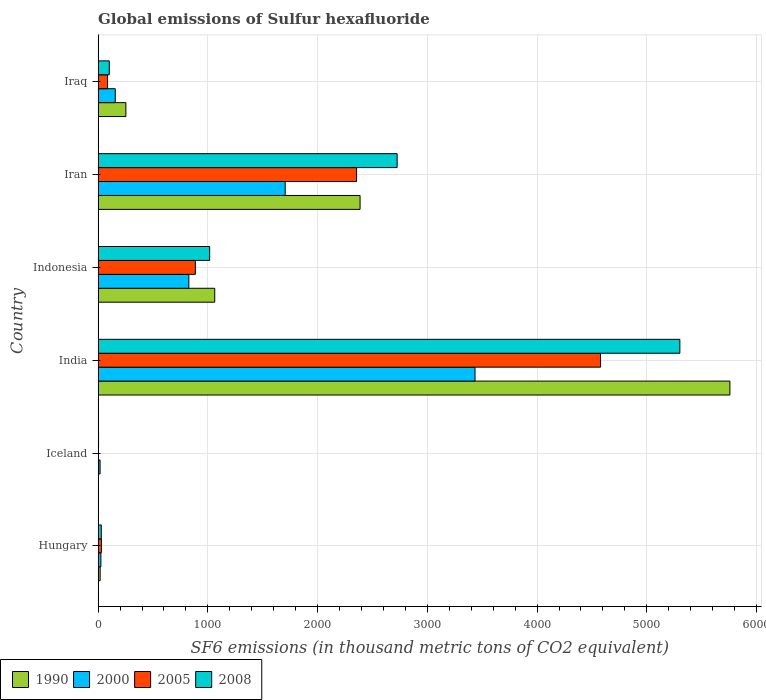How many different coloured bars are there?
Keep it short and to the point. 4. How many groups of bars are there?
Give a very brief answer. 6. Are the number of bars per tick equal to the number of legend labels?
Your answer should be very brief. Yes. Are the number of bars on each tick of the Y-axis equal?
Offer a terse response. Yes. How many bars are there on the 1st tick from the top?
Give a very brief answer. 4. What is the global emissions of Sulfur hexafluoride in 2000 in Iran?
Provide a short and direct response. 1704.9. Across all countries, what is the maximum global emissions of Sulfur hexafluoride in 2008?
Ensure brevity in your answer.  5301.4. Across all countries, what is the minimum global emissions of Sulfur hexafluoride in 2008?
Keep it short and to the point. 4. In which country was the global emissions of Sulfur hexafluoride in 2008 maximum?
Your response must be concise. India. In which country was the global emissions of Sulfur hexafluoride in 2000 minimum?
Provide a short and direct response. Iceland. What is the total global emissions of Sulfur hexafluoride in 1990 in the graph?
Your answer should be very brief. 9482.6. What is the difference between the global emissions of Sulfur hexafluoride in 1990 in India and that in Indonesia?
Provide a short and direct response. 4694.7. What is the difference between the global emissions of Sulfur hexafluoride in 2005 in Iran and the global emissions of Sulfur hexafluoride in 1990 in Indonesia?
Make the answer very short. 1292.7. What is the average global emissions of Sulfur hexafluoride in 2000 per country?
Make the answer very short. 1027.6. What is the difference between the global emissions of Sulfur hexafluoride in 2005 and global emissions of Sulfur hexafluoride in 2008 in Hungary?
Give a very brief answer. 1.1. In how many countries, is the global emissions of Sulfur hexafluoride in 2008 greater than 3200 thousand metric tons?
Make the answer very short. 1. What is the ratio of the global emissions of Sulfur hexafluoride in 1990 in Iceland to that in Iraq?
Ensure brevity in your answer.  0.01. Is the difference between the global emissions of Sulfur hexafluoride in 2005 in Indonesia and Iran greater than the difference between the global emissions of Sulfur hexafluoride in 2008 in Indonesia and Iran?
Keep it short and to the point. Yes. What is the difference between the highest and the second highest global emissions of Sulfur hexafluoride in 2008?
Ensure brevity in your answer.  2576.5. What is the difference between the highest and the lowest global emissions of Sulfur hexafluoride in 2000?
Keep it short and to the point. 3416.8. In how many countries, is the global emissions of Sulfur hexafluoride in 2005 greater than the average global emissions of Sulfur hexafluoride in 2005 taken over all countries?
Your answer should be very brief. 2. Is the sum of the global emissions of Sulfur hexafluoride in 2000 in Iceland and India greater than the maximum global emissions of Sulfur hexafluoride in 2008 across all countries?
Your answer should be very brief. No. What does the 1st bar from the top in Iceland represents?
Your answer should be compact. 2008. Are all the bars in the graph horizontal?
Give a very brief answer. Yes. Where does the legend appear in the graph?
Provide a succinct answer. Bottom left. How are the legend labels stacked?
Offer a very short reply. Horizontal. What is the title of the graph?
Offer a very short reply. Global emissions of Sulfur hexafluoride. What is the label or title of the X-axis?
Ensure brevity in your answer.  SF6 emissions (in thousand metric tons of CO2 equivalent). What is the label or title of the Y-axis?
Your answer should be compact. Country. What is the SF6 emissions (in thousand metric tons of CO2 equivalent) of 1990 in Hungary?
Ensure brevity in your answer.  18.6. What is the SF6 emissions (in thousand metric tons of CO2 equivalent) of 2000 in Hungary?
Make the answer very short. 25.2. What is the SF6 emissions (in thousand metric tons of CO2 equivalent) in 2008 in Hungary?
Your answer should be compact. 28.9. What is the SF6 emissions (in thousand metric tons of CO2 equivalent) of 2000 in Iceland?
Provide a succinct answer. 17.9. What is the SF6 emissions (in thousand metric tons of CO2 equivalent) of 1990 in India?
Your response must be concise. 5757.5. What is the SF6 emissions (in thousand metric tons of CO2 equivalent) in 2000 in India?
Keep it short and to the point. 3434.7. What is the SF6 emissions (in thousand metric tons of CO2 equivalent) of 2005 in India?
Keep it short and to the point. 4578.7. What is the SF6 emissions (in thousand metric tons of CO2 equivalent) of 2008 in India?
Your answer should be compact. 5301.4. What is the SF6 emissions (in thousand metric tons of CO2 equivalent) of 1990 in Indonesia?
Your answer should be compact. 1062.8. What is the SF6 emissions (in thousand metric tons of CO2 equivalent) of 2000 in Indonesia?
Provide a succinct answer. 826.8. What is the SF6 emissions (in thousand metric tons of CO2 equivalent) of 2005 in Indonesia?
Provide a short and direct response. 886.1. What is the SF6 emissions (in thousand metric tons of CO2 equivalent) in 2008 in Indonesia?
Give a very brief answer. 1016.4. What is the SF6 emissions (in thousand metric tons of CO2 equivalent) in 1990 in Iran?
Your response must be concise. 2387.3. What is the SF6 emissions (in thousand metric tons of CO2 equivalent) in 2000 in Iran?
Make the answer very short. 1704.9. What is the SF6 emissions (in thousand metric tons of CO2 equivalent) of 2005 in Iran?
Your answer should be compact. 2355.5. What is the SF6 emissions (in thousand metric tons of CO2 equivalent) in 2008 in Iran?
Offer a terse response. 2724.9. What is the SF6 emissions (in thousand metric tons of CO2 equivalent) of 1990 in Iraq?
Provide a short and direct response. 252.9. What is the SF6 emissions (in thousand metric tons of CO2 equivalent) in 2000 in Iraq?
Make the answer very short. 156.1. What is the SF6 emissions (in thousand metric tons of CO2 equivalent) in 2008 in Iraq?
Offer a terse response. 101.7. Across all countries, what is the maximum SF6 emissions (in thousand metric tons of CO2 equivalent) in 1990?
Keep it short and to the point. 5757.5. Across all countries, what is the maximum SF6 emissions (in thousand metric tons of CO2 equivalent) of 2000?
Your response must be concise. 3434.7. Across all countries, what is the maximum SF6 emissions (in thousand metric tons of CO2 equivalent) of 2005?
Offer a terse response. 4578.7. Across all countries, what is the maximum SF6 emissions (in thousand metric tons of CO2 equivalent) in 2008?
Provide a short and direct response. 5301.4. Across all countries, what is the minimum SF6 emissions (in thousand metric tons of CO2 equivalent) in 1990?
Give a very brief answer. 3.5. Across all countries, what is the minimum SF6 emissions (in thousand metric tons of CO2 equivalent) of 2005?
Provide a succinct answer. 3.5. What is the total SF6 emissions (in thousand metric tons of CO2 equivalent) in 1990 in the graph?
Your answer should be compact. 9482.6. What is the total SF6 emissions (in thousand metric tons of CO2 equivalent) of 2000 in the graph?
Offer a very short reply. 6165.6. What is the total SF6 emissions (in thousand metric tons of CO2 equivalent) in 2005 in the graph?
Your response must be concise. 7939.8. What is the total SF6 emissions (in thousand metric tons of CO2 equivalent) in 2008 in the graph?
Your answer should be compact. 9177.3. What is the difference between the SF6 emissions (in thousand metric tons of CO2 equivalent) in 1990 in Hungary and that in Iceland?
Provide a short and direct response. 15.1. What is the difference between the SF6 emissions (in thousand metric tons of CO2 equivalent) in 2000 in Hungary and that in Iceland?
Ensure brevity in your answer.  7.3. What is the difference between the SF6 emissions (in thousand metric tons of CO2 equivalent) of 2008 in Hungary and that in Iceland?
Keep it short and to the point. 24.9. What is the difference between the SF6 emissions (in thousand metric tons of CO2 equivalent) of 1990 in Hungary and that in India?
Make the answer very short. -5738.9. What is the difference between the SF6 emissions (in thousand metric tons of CO2 equivalent) in 2000 in Hungary and that in India?
Ensure brevity in your answer.  -3409.5. What is the difference between the SF6 emissions (in thousand metric tons of CO2 equivalent) in 2005 in Hungary and that in India?
Make the answer very short. -4548.7. What is the difference between the SF6 emissions (in thousand metric tons of CO2 equivalent) of 2008 in Hungary and that in India?
Provide a succinct answer. -5272.5. What is the difference between the SF6 emissions (in thousand metric tons of CO2 equivalent) in 1990 in Hungary and that in Indonesia?
Your answer should be compact. -1044.2. What is the difference between the SF6 emissions (in thousand metric tons of CO2 equivalent) of 2000 in Hungary and that in Indonesia?
Keep it short and to the point. -801.6. What is the difference between the SF6 emissions (in thousand metric tons of CO2 equivalent) of 2005 in Hungary and that in Indonesia?
Ensure brevity in your answer.  -856.1. What is the difference between the SF6 emissions (in thousand metric tons of CO2 equivalent) in 2008 in Hungary and that in Indonesia?
Your answer should be compact. -987.5. What is the difference between the SF6 emissions (in thousand metric tons of CO2 equivalent) of 1990 in Hungary and that in Iran?
Ensure brevity in your answer.  -2368.7. What is the difference between the SF6 emissions (in thousand metric tons of CO2 equivalent) in 2000 in Hungary and that in Iran?
Make the answer very short. -1679.7. What is the difference between the SF6 emissions (in thousand metric tons of CO2 equivalent) in 2005 in Hungary and that in Iran?
Offer a terse response. -2325.5. What is the difference between the SF6 emissions (in thousand metric tons of CO2 equivalent) of 2008 in Hungary and that in Iran?
Offer a terse response. -2696. What is the difference between the SF6 emissions (in thousand metric tons of CO2 equivalent) in 1990 in Hungary and that in Iraq?
Give a very brief answer. -234.3. What is the difference between the SF6 emissions (in thousand metric tons of CO2 equivalent) in 2000 in Hungary and that in Iraq?
Ensure brevity in your answer.  -130.9. What is the difference between the SF6 emissions (in thousand metric tons of CO2 equivalent) in 2005 in Hungary and that in Iraq?
Give a very brief answer. -56. What is the difference between the SF6 emissions (in thousand metric tons of CO2 equivalent) in 2008 in Hungary and that in Iraq?
Make the answer very short. -72.8. What is the difference between the SF6 emissions (in thousand metric tons of CO2 equivalent) of 1990 in Iceland and that in India?
Provide a short and direct response. -5754. What is the difference between the SF6 emissions (in thousand metric tons of CO2 equivalent) of 2000 in Iceland and that in India?
Your answer should be very brief. -3416.8. What is the difference between the SF6 emissions (in thousand metric tons of CO2 equivalent) in 2005 in Iceland and that in India?
Keep it short and to the point. -4575.2. What is the difference between the SF6 emissions (in thousand metric tons of CO2 equivalent) in 2008 in Iceland and that in India?
Offer a very short reply. -5297.4. What is the difference between the SF6 emissions (in thousand metric tons of CO2 equivalent) in 1990 in Iceland and that in Indonesia?
Ensure brevity in your answer.  -1059.3. What is the difference between the SF6 emissions (in thousand metric tons of CO2 equivalent) in 2000 in Iceland and that in Indonesia?
Provide a short and direct response. -808.9. What is the difference between the SF6 emissions (in thousand metric tons of CO2 equivalent) of 2005 in Iceland and that in Indonesia?
Your answer should be compact. -882.6. What is the difference between the SF6 emissions (in thousand metric tons of CO2 equivalent) in 2008 in Iceland and that in Indonesia?
Make the answer very short. -1012.4. What is the difference between the SF6 emissions (in thousand metric tons of CO2 equivalent) of 1990 in Iceland and that in Iran?
Make the answer very short. -2383.8. What is the difference between the SF6 emissions (in thousand metric tons of CO2 equivalent) of 2000 in Iceland and that in Iran?
Offer a very short reply. -1687. What is the difference between the SF6 emissions (in thousand metric tons of CO2 equivalent) of 2005 in Iceland and that in Iran?
Ensure brevity in your answer.  -2352. What is the difference between the SF6 emissions (in thousand metric tons of CO2 equivalent) in 2008 in Iceland and that in Iran?
Provide a short and direct response. -2720.9. What is the difference between the SF6 emissions (in thousand metric tons of CO2 equivalent) in 1990 in Iceland and that in Iraq?
Offer a very short reply. -249.4. What is the difference between the SF6 emissions (in thousand metric tons of CO2 equivalent) in 2000 in Iceland and that in Iraq?
Provide a short and direct response. -138.2. What is the difference between the SF6 emissions (in thousand metric tons of CO2 equivalent) in 2005 in Iceland and that in Iraq?
Make the answer very short. -82.5. What is the difference between the SF6 emissions (in thousand metric tons of CO2 equivalent) of 2008 in Iceland and that in Iraq?
Offer a very short reply. -97.7. What is the difference between the SF6 emissions (in thousand metric tons of CO2 equivalent) in 1990 in India and that in Indonesia?
Your response must be concise. 4694.7. What is the difference between the SF6 emissions (in thousand metric tons of CO2 equivalent) in 2000 in India and that in Indonesia?
Offer a terse response. 2607.9. What is the difference between the SF6 emissions (in thousand metric tons of CO2 equivalent) of 2005 in India and that in Indonesia?
Keep it short and to the point. 3692.6. What is the difference between the SF6 emissions (in thousand metric tons of CO2 equivalent) of 2008 in India and that in Indonesia?
Offer a very short reply. 4285. What is the difference between the SF6 emissions (in thousand metric tons of CO2 equivalent) of 1990 in India and that in Iran?
Give a very brief answer. 3370.2. What is the difference between the SF6 emissions (in thousand metric tons of CO2 equivalent) in 2000 in India and that in Iran?
Offer a very short reply. 1729.8. What is the difference between the SF6 emissions (in thousand metric tons of CO2 equivalent) in 2005 in India and that in Iran?
Ensure brevity in your answer.  2223.2. What is the difference between the SF6 emissions (in thousand metric tons of CO2 equivalent) in 2008 in India and that in Iran?
Offer a very short reply. 2576.5. What is the difference between the SF6 emissions (in thousand metric tons of CO2 equivalent) in 1990 in India and that in Iraq?
Offer a very short reply. 5504.6. What is the difference between the SF6 emissions (in thousand metric tons of CO2 equivalent) in 2000 in India and that in Iraq?
Your answer should be compact. 3278.6. What is the difference between the SF6 emissions (in thousand metric tons of CO2 equivalent) in 2005 in India and that in Iraq?
Offer a very short reply. 4492.7. What is the difference between the SF6 emissions (in thousand metric tons of CO2 equivalent) in 2008 in India and that in Iraq?
Your answer should be very brief. 5199.7. What is the difference between the SF6 emissions (in thousand metric tons of CO2 equivalent) in 1990 in Indonesia and that in Iran?
Provide a short and direct response. -1324.5. What is the difference between the SF6 emissions (in thousand metric tons of CO2 equivalent) of 2000 in Indonesia and that in Iran?
Give a very brief answer. -878.1. What is the difference between the SF6 emissions (in thousand metric tons of CO2 equivalent) of 2005 in Indonesia and that in Iran?
Offer a terse response. -1469.4. What is the difference between the SF6 emissions (in thousand metric tons of CO2 equivalent) in 2008 in Indonesia and that in Iran?
Offer a terse response. -1708.5. What is the difference between the SF6 emissions (in thousand metric tons of CO2 equivalent) in 1990 in Indonesia and that in Iraq?
Give a very brief answer. 809.9. What is the difference between the SF6 emissions (in thousand metric tons of CO2 equivalent) in 2000 in Indonesia and that in Iraq?
Ensure brevity in your answer.  670.7. What is the difference between the SF6 emissions (in thousand metric tons of CO2 equivalent) in 2005 in Indonesia and that in Iraq?
Provide a succinct answer. 800.1. What is the difference between the SF6 emissions (in thousand metric tons of CO2 equivalent) in 2008 in Indonesia and that in Iraq?
Offer a very short reply. 914.7. What is the difference between the SF6 emissions (in thousand metric tons of CO2 equivalent) in 1990 in Iran and that in Iraq?
Give a very brief answer. 2134.4. What is the difference between the SF6 emissions (in thousand metric tons of CO2 equivalent) in 2000 in Iran and that in Iraq?
Offer a terse response. 1548.8. What is the difference between the SF6 emissions (in thousand metric tons of CO2 equivalent) in 2005 in Iran and that in Iraq?
Keep it short and to the point. 2269.5. What is the difference between the SF6 emissions (in thousand metric tons of CO2 equivalent) of 2008 in Iran and that in Iraq?
Give a very brief answer. 2623.2. What is the difference between the SF6 emissions (in thousand metric tons of CO2 equivalent) in 1990 in Hungary and the SF6 emissions (in thousand metric tons of CO2 equivalent) in 2008 in Iceland?
Offer a very short reply. 14.6. What is the difference between the SF6 emissions (in thousand metric tons of CO2 equivalent) of 2000 in Hungary and the SF6 emissions (in thousand metric tons of CO2 equivalent) of 2005 in Iceland?
Offer a very short reply. 21.7. What is the difference between the SF6 emissions (in thousand metric tons of CO2 equivalent) in 2000 in Hungary and the SF6 emissions (in thousand metric tons of CO2 equivalent) in 2008 in Iceland?
Keep it short and to the point. 21.2. What is the difference between the SF6 emissions (in thousand metric tons of CO2 equivalent) in 1990 in Hungary and the SF6 emissions (in thousand metric tons of CO2 equivalent) in 2000 in India?
Your answer should be very brief. -3416.1. What is the difference between the SF6 emissions (in thousand metric tons of CO2 equivalent) of 1990 in Hungary and the SF6 emissions (in thousand metric tons of CO2 equivalent) of 2005 in India?
Your answer should be compact. -4560.1. What is the difference between the SF6 emissions (in thousand metric tons of CO2 equivalent) of 1990 in Hungary and the SF6 emissions (in thousand metric tons of CO2 equivalent) of 2008 in India?
Ensure brevity in your answer.  -5282.8. What is the difference between the SF6 emissions (in thousand metric tons of CO2 equivalent) of 2000 in Hungary and the SF6 emissions (in thousand metric tons of CO2 equivalent) of 2005 in India?
Provide a short and direct response. -4553.5. What is the difference between the SF6 emissions (in thousand metric tons of CO2 equivalent) in 2000 in Hungary and the SF6 emissions (in thousand metric tons of CO2 equivalent) in 2008 in India?
Keep it short and to the point. -5276.2. What is the difference between the SF6 emissions (in thousand metric tons of CO2 equivalent) in 2005 in Hungary and the SF6 emissions (in thousand metric tons of CO2 equivalent) in 2008 in India?
Offer a very short reply. -5271.4. What is the difference between the SF6 emissions (in thousand metric tons of CO2 equivalent) of 1990 in Hungary and the SF6 emissions (in thousand metric tons of CO2 equivalent) of 2000 in Indonesia?
Give a very brief answer. -808.2. What is the difference between the SF6 emissions (in thousand metric tons of CO2 equivalent) in 1990 in Hungary and the SF6 emissions (in thousand metric tons of CO2 equivalent) in 2005 in Indonesia?
Make the answer very short. -867.5. What is the difference between the SF6 emissions (in thousand metric tons of CO2 equivalent) in 1990 in Hungary and the SF6 emissions (in thousand metric tons of CO2 equivalent) in 2008 in Indonesia?
Your answer should be compact. -997.8. What is the difference between the SF6 emissions (in thousand metric tons of CO2 equivalent) in 2000 in Hungary and the SF6 emissions (in thousand metric tons of CO2 equivalent) in 2005 in Indonesia?
Make the answer very short. -860.9. What is the difference between the SF6 emissions (in thousand metric tons of CO2 equivalent) of 2000 in Hungary and the SF6 emissions (in thousand metric tons of CO2 equivalent) of 2008 in Indonesia?
Offer a terse response. -991.2. What is the difference between the SF6 emissions (in thousand metric tons of CO2 equivalent) in 2005 in Hungary and the SF6 emissions (in thousand metric tons of CO2 equivalent) in 2008 in Indonesia?
Offer a very short reply. -986.4. What is the difference between the SF6 emissions (in thousand metric tons of CO2 equivalent) in 1990 in Hungary and the SF6 emissions (in thousand metric tons of CO2 equivalent) in 2000 in Iran?
Offer a very short reply. -1686.3. What is the difference between the SF6 emissions (in thousand metric tons of CO2 equivalent) of 1990 in Hungary and the SF6 emissions (in thousand metric tons of CO2 equivalent) of 2005 in Iran?
Your response must be concise. -2336.9. What is the difference between the SF6 emissions (in thousand metric tons of CO2 equivalent) in 1990 in Hungary and the SF6 emissions (in thousand metric tons of CO2 equivalent) in 2008 in Iran?
Make the answer very short. -2706.3. What is the difference between the SF6 emissions (in thousand metric tons of CO2 equivalent) in 2000 in Hungary and the SF6 emissions (in thousand metric tons of CO2 equivalent) in 2005 in Iran?
Offer a terse response. -2330.3. What is the difference between the SF6 emissions (in thousand metric tons of CO2 equivalent) in 2000 in Hungary and the SF6 emissions (in thousand metric tons of CO2 equivalent) in 2008 in Iran?
Your answer should be very brief. -2699.7. What is the difference between the SF6 emissions (in thousand metric tons of CO2 equivalent) of 2005 in Hungary and the SF6 emissions (in thousand metric tons of CO2 equivalent) of 2008 in Iran?
Offer a terse response. -2694.9. What is the difference between the SF6 emissions (in thousand metric tons of CO2 equivalent) of 1990 in Hungary and the SF6 emissions (in thousand metric tons of CO2 equivalent) of 2000 in Iraq?
Give a very brief answer. -137.5. What is the difference between the SF6 emissions (in thousand metric tons of CO2 equivalent) in 1990 in Hungary and the SF6 emissions (in thousand metric tons of CO2 equivalent) in 2005 in Iraq?
Ensure brevity in your answer.  -67.4. What is the difference between the SF6 emissions (in thousand metric tons of CO2 equivalent) of 1990 in Hungary and the SF6 emissions (in thousand metric tons of CO2 equivalent) of 2008 in Iraq?
Offer a very short reply. -83.1. What is the difference between the SF6 emissions (in thousand metric tons of CO2 equivalent) in 2000 in Hungary and the SF6 emissions (in thousand metric tons of CO2 equivalent) in 2005 in Iraq?
Your answer should be compact. -60.8. What is the difference between the SF6 emissions (in thousand metric tons of CO2 equivalent) in 2000 in Hungary and the SF6 emissions (in thousand metric tons of CO2 equivalent) in 2008 in Iraq?
Provide a succinct answer. -76.5. What is the difference between the SF6 emissions (in thousand metric tons of CO2 equivalent) in 2005 in Hungary and the SF6 emissions (in thousand metric tons of CO2 equivalent) in 2008 in Iraq?
Offer a very short reply. -71.7. What is the difference between the SF6 emissions (in thousand metric tons of CO2 equivalent) of 1990 in Iceland and the SF6 emissions (in thousand metric tons of CO2 equivalent) of 2000 in India?
Offer a very short reply. -3431.2. What is the difference between the SF6 emissions (in thousand metric tons of CO2 equivalent) in 1990 in Iceland and the SF6 emissions (in thousand metric tons of CO2 equivalent) in 2005 in India?
Your answer should be very brief. -4575.2. What is the difference between the SF6 emissions (in thousand metric tons of CO2 equivalent) of 1990 in Iceland and the SF6 emissions (in thousand metric tons of CO2 equivalent) of 2008 in India?
Provide a succinct answer. -5297.9. What is the difference between the SF6 emissions (in thousand metric tons of CO2 equivalent) in 2000 in Iceland and the SF6 emissions (in thousand metric tons of CO2 equivalent) in 2005 in India?
Provide a short and direct response. -4560.8. What is the difference between the SF6 emissions (in thousand metric tons of CO2 equivalent) of 2000 in Iceland and the SF6 emissions (in thousand metric tons of CO2 equivalent) of 2008 in India?
Offer a terse response. -5283.5. What is the difference between the SF6 emissions (in thousand metric tons of CO2 equivalent) of 2005 in Iceland and the SF6 emissions (in thousand metric tons of CO2 equivalent) of 2008 in India?
Ensure brevity in your answer.  -5297.9. What is the difference between the SF6 emissions (in thousand metric tons of CO2 equivalent) of 1990 in Iceland and the SF6 emissions (in thousand metric tons of CO2 equivalent) of 2000 in Indonesia?
Your answer should be very brief. -823.3. What is the difference between the SF6 emissions (in thousand metric tons of CO2 equivalent) in 1990 in Iceland and the SF6 emissions (in thousand metric tons of CO2 equivalent) in 2005 in Indonesia?
Provide a short and direct response. -882.6. What is the difference between the SF6 emissions (in thousand metric tons of CO2 equivalent) in 1990 in Iceland and the SF6 emissions (in thousand metric tons of CO2 equivalent) in 2008 in Indonesia?
Your answer should be compact. -1012.9. What is the difference between the SF6 emissions (in thousand metric tons of CO2 equivalent) of 2000 in Iceland and the SF6 emissions (in thousand metric tons of CO2 equivalent) of 2005 in Indonesia?
Your answer should be very brief. -868.2. What is the difference between the SF6 emissions (in thousand metric tons of CO2 equivalent) in 2000 in Iceland and the SF6 emissions (in thousand metric tons of CO2 equivalent) in 2008 in Indonesia?
Ensure brevity in your answer.  -998.5. What is the difference between the SF6 emissions (in thousand metric tons of CO2 equivalent) in 2005 in Iceland and the SF6 emissions (in thousand metric tons of CO2 equivalent) in 2008 in Indonesia?
Your answer should be very brief. -1012.9. What is the difference between the SF6 emissions (in thousand metric tons of CO2 equivalent) in 1990 in Iceland and the SF6 emissions (in thousand metric tons of CO2 equivalent) in 2000 in Iran?
Your response must be concise. -1701.4. What is the difference between the SF6 emissions (in thousand metric tons of CO2 equivalent) in 1990 in Iceland and the SF6 emissions (in thousand metric tons of CO2 equivalent) in 2005 in Iran?
Offer a very short reply. -2352. What is the difference between the SF6 emissions (in thousand metric tons of CO2 equivalent) in 1990 in Iceland and the SF6 emissions (in thousand metric tons of CO2 equivalent) in 2008 in Iran?
Give a very brief answer. -2721.4. What is the difference between the SF6 emissions (in thousand metric tons of CO2 equivalent) in 2000 in Iceland and the SF6 emissions (in thousand metric tons of CO2 equivalent) in 2005 in Iran?
Give a very brief answer. -2337.6. What is the difference between the SF6 emissions (in thousand metric tons of CO2 equivalent) of 2000 in Iceland and the SF6 emissions (in thousand metric tons of CO2 equivalent) of 2008 in Iran?
Your response must be concise. -2707. What is the difference between the SF6 emissions (in thousand metric tons of CO2 equivalent) of 2005 in Iceland and the SF6 emissions (in thousand metric tons of CO2 equivalent) of 2008 in Iran?
Your answer should be very brief. -2721.4. What is the difference between the SF6 emissions (in thousand metric tons of CO2 equivalent) of 1990 in Iceland and the SF6 emissions (in thousand metric tons of CO2 equivalent) of 2000 in Iraq?
Your answer should be very brief. -152.6. What is the difference between the SF6 emissions (in thousand metric tons of CO2 equivalent) in 1990 in Iceland and the SF6 emissions (in thousand metric tons of CO2 equivalent) in 2005 in Iraq?
Offer a terse response. -82.5. What is the difference between the SF6 emissions (in thousand metric tons of CO2 equivalent) in 1990 in Iceland and the SF6 emissions (in thousand metric tons of CO2 equivalent) in 2008 in Iraq?
Give a very brief answer. -98.2. What is the difference between the SF6 emissions (in thousand metric tons of CO2 equivalent) of 2000 in Iceland and the SF6 emissions (in thousand metric tons of CO2 equivalent) of 2005 in Iraq?
Provide a short and direct response. -68.1. What is the difference between the SF6 emissions (in thousand metric tons of CO2 equivalent) in 2000 in Iceland and the SF6 emissions (in thousand metric tons of CO2 equivalent) in 2008 in Iraq?
Offer a very short reply. -83.8. What is the difference between the SF6 emissions (in thousand metric tons of CO2 equivalent) of 2005 in Iceland and the SF6 emissions (in thousand metric tons of CO2 equivalent) of 2008 in Iraq?
Keep it short and to the point. -98.2. What is the difference between the SF6 emissions (in thousand metric tons of CO2 equivalent) of 1990 in India and the SF6 emissions (in thousand metric tons of CO2 equivalent) of 2000 in Indonesia?
Keep it short and to the point. 4930.7. What is the difference between the SF6 emissions (in thousand metric tons of CO2 equivalent) in 1990 in India and the SF6 emissions (in thousand metric tons of CO2 equivalent) in 2005 in Indonesia?
Your response must be concise. 4871.4. What is the difference between the SF6 emissions (in thousand metric tons of CO2 equivalent) in 1990 in India and the SF6 emissions (in thousand metric tons of CO2 equivalent) in 2008 in Indonesia?
Give a very brief answer. 4741.1. What is the difference between the SF6 emissions (in thousand metric tons of CO2 equivalent) of 2000 in India and the SF6 emissions (in thousand metric tons of CO2 equivalent) of 2005 in Indonesia?
Your response must be concise. 2548.6. What is the difference between the SF6 emissions (in thousand metric tons of CO2 equivalent) of 2000 in India and the SF6 emissions (in thousand metric tons of CO2 equivalent) of 2008 in Indonesia?
Make the answer very short. 2418.3. What is the difference between the SF6 emissions (in thousand metric tons of CO2 equivalent) of 2005 in India and the SF6 emissions (in thousand metric tons of CO2 equivalent) of 2008 in Indonesia?
Provide a short and direct response. 3562.3. What is the difference between the SF6 emissions (in thousand metric tons of CO2 equivalent) of 1990 in India and the SF6 emissions (in thousand metric tons of CO2 equivalent) of 2000 in Iran?
Offer a terse response. 4052.6. What is the difference between the SF6 emissions (in thousand metric tons of CO2 equivalent) in 1990 in India and the SF6 emissions (in thousand metric tons of CO2 equivalent) in 2005 in Iran?
Your answer should be compact. 3402. What is the difference between the SF6 emissions (in thousand metric tons of CO2 equivalent) of 1990 in India and the SF6 emissions (in thousand metric tons of CO2 equivalent) of 2008 in Iran?
Provide a succinct answer. 3032.6. What is the difference between the SF6 emissions (in thousand metric tons of CO2 equivalent) of 2000 in India and the SF6 emissions (in thousand metric tons of CO2 equivalent) of 2005 in Iran?
Provide a short and direct response. 1079.2. What is the difference between the SF6 emissions (in thousand metric tons of CO2 equivalent) in 2000 in India and the SF6 emissions (in thousand metric tons of CO2 equivalent) in 2008 in Iran?
Offer a very short reply. 709.8. What is the difference between the SF6 emissions (in thousand metric tons of CO2 equivalent) in 2005 in India and the SF6 emissions (in thousand metric tons of CO2 equivalent) in 2008 in Iran?
Offer a very short reply. 1853.8. What is the difference between the SF6 emissions (in thousand metric tons of CO2 equivalent) in 1990 in India and the SF6 emissions (in thousand metric tons of CO2 equivalent) in 2000 in Iraq?
Provide a short and direct response. 5601.4. What is the difference between the SF6 emissions (in thousand metric tons of CO2 equivalent) in 1990 in India and the SF6 emissions (in thousand metric tons of CO2 equivalent) in 2005 in Iraq?
Give a very brief answer. 5671.5. What is the difference between the SF6 emissions (in thousand metric tons of CO2 equivalent) in 1990 in India and the SF6 emissions (in thousand metric tons of CO2 equivalent) in 2008 in Iraq?
Provide a short and direct response. 5655.8. What is the difference between the SF6 emissions (in thousand metric tons of CO2 equivalent) in 2000 in India and the SF6 emissions (in thousand metric tons of CO2 equivalent) in 2005 in Iraq?
Your response must be concise. 3348.7. What is the difference between the SF6 emissions (in thousand metric tons of CO2 equivalent) in 2000 in India and the SF6 emissions (in thousand metric tons of CO2 equivalent) in 2008 in Iraq?
Ensure brevity in your answer.  3333. What is the difference between the SF6 emissions (in thousand metric tons of CO2 equivalent) of 2005 in India and the SF6 emissions (in thousand metric tons of CO2 equivalent) of 2008 in Iraq?
Offer a very short reply. 4477. What is the difference between the SF6 emissions (in thousand metric tons of CO2 equivalent) of 1990 in Indonesia and the SF6 emissions (in thousand metric tons of CO2 equivalent) of 2000 in Iran?
Keep it short and to the point. -642.1. What is the difference between the SF6 emissions (in thousand metric tons of CO2 equivalent) in 1990 in Indonesia and the SF6 emissions (in thousand metric tons of CO2 equivalent) in 2005 in Iran?
Ensure brevity in your answer.  -1292.7. What is the difference between the SF6 emissions (in thousand metric tons of CO2 equivalent) of 1990 in Indonesia and the SF6 emissions (in thousand metric tons of CO2 equivalent) of 2008 in Iran?
Provide a succinct answer. -1662.1. What is the difference between the SF6 emissions (in thousand metric tons of CO2 equivalent) of 2000 in Indonesia and the SF6 emissions (in thousand metric tons of CO2 equivalent) of 2005 in Iran?
Your answer should be very brief. -1528.7. What is the difference between the SF6 emissions (in thousand metric tons of CO2 equivalent) in 2000 in Indonesia and the SF6 emissions (in thousand metric tons of CO2 equivalent) in 2008 in Iran?
Ensure brevity in your answer.  -1898.1. What is the difference between the SF6 emissions (in thousand metric tons of CO2 equivalent) in 2005 in Indonesia and the SF6 emissions (in thousand metric tons of CO2 equivalent) in 2008 in Iran?
Offer a very short reply. -1838.8. What is the difference between the SF6 emissions (in thousand metric tons of CO2 equivalent) in 1990 in Indonesia and the SF6 emissions (in thousand metric tons of CO2 equivalent) in 2000 in Iraq?
Provide a succinct answer. 906.7. What is the difference between the SF6 emissions (in thousand metric tons of CO2 equivalent) of 1990 in Indonesia and the SF6 emissions (in thousand metric tons of CO2 equivalent) of 2005 in Iraq?
Make the answer very short. 976.8. What is the difference between the SF6 emissions (in thousand metric tons of CO2 equivalent) in 1990 in Indonesia and the SF6 emissions (in thousand metric tons of CO2 equivalent) in 2008 in Iraq?
Your answer should be very brief. 961.1. What is the difference between the SF6 emissions (in thousand metric tons of CO2 equivalent) in 2000 in Indonesia and the SF6 emissions (in thousand metric tons of CO2 equivalent) in 2005 in Iraq?
Your answer should be compact. 740.8. What is the difference between the SF6 emissions (in thousand metric tons of CO2 equivalent) of 2000 in Indonesia and the SF6 emissions (in thousand metric tons of CO2 equivalent) of 2008 in Iraq?
Provide a succinct answer. 725.1. What is the difference between the SF6 emissions (in thousand metric tons of CO2 equivalent) in 2005 in Indonesia and the SF6 emissions (in thousand metric tons of CO2 equivalent) in 2008 in Iraq?
Your answer should be very brief. 784.4. What is the difference between the SF6 emissions (in thousand metric tons of CO2 equivalent) of 1990 in Iran and the SF6 emissions (in thousand metric tons of CO2 equivalent) of 2000 in Iraq?
Offer a very short reply. 2231.2. What is the difference between the SF6 emissions (in thousand metric tons of CO2 equivalent) of 1990 in Iran and the SF6 emissions (in thousand metric tons of CO2 equivalent) of 2005 in Iraq?
Offer a terse response. 2301.3. What is the difference between the SF6 emissions (in thousand metric tons of CO2 equivalent) in 1990 in Iran and the SF6 emissions (in thousand metric tons of CO2 equivalent) in 2008 in Iraq?
Provide a succinct answer. 2285.6. What is the difference between the SF6 emissions (in thousand metric tons of CO2 equivalent) in 2000 in Iran and the SF6 emissions (in thousand metric tons of CO2 equivalent) in 2005 in Iraq?
Provide a succinct answer. 1618.9. What is the difference between the SF6 emissions (in thousand metric tons of CO2 equivalent) of 2000 in Iran and the SF6 emissions (in thousand metric tons of CO2 equivalent) of 2008 in Iraq?
Make the answer very short. 1603.2. What is the difference between the SF6 emissions (in thousand metric tons of CO2 equivalent) of 2005 in Iran and the SF6 emissions (in thousand metric tons of CO2 equivalent) of 2008 in Iraq?
Your answer should be compact. 2253.8. What is the average SF6 emissions (in thousand metric tons of CO2 equivalent) of 1990 per country?
Your answer should be compact. 1580.43. What is the average SF6 emissions (in thousand metric tons of CO2 equivalent) of 2000 per country?
Give a very brief answer. 1027.6. What is the average SF6 emissions (in thousand metric tons of CO2 equivalent) of 2005 per country?
Offer a terse response. 1323.3. What is the average SF6 emissions (in thousand metric tons of CO2 equivalent) in 2008 per country?
Your answer should be very brief. 1529.55. What is the difference between the SF6 emissions (in thousand metric tons of CO2 equivalent) in 1990 and SF6 emissions (in thousand metric tons of CO2 equivalent) in 2000 in Hungary?
Keep it short and to the point. -6.6. What is the difference between the SF6 emissions (in thousand metric tons of CO2 equivalent) of 1990 and SF6 emissions (in thousand metric tons of CO2 equivalent) of 2005 in Hungary?
Provide a short and direct response. -11.4. What is the difference between the SF6 emissions (in thousand metric tons of CO2 equivalent) in 1990 and SF6 emissions (in thousand metric tons of CO2 equivalent) in 2008 in Hungary?
Offer a terse response. -10.3. What is the difference between the SF6 emissions (in thousand metric tons of CO2 equivalent) in 2000 and SF6 emissions (in thousand metric tons of CO2 equivalent) in 2005 in Hungary?
Make the answer very short. -4.8. What is the difference between the SF6 emissions (in thousand metric tons of CO2 equivalent) in 1990 and SF6 emissions (in thousand metric tons of CO2 equivalent) in 2000 in Iceland?
Your answer should be very brief. -14.4. What is the difference between the SF6 emissions (in thousand metric tons of CO2 equivalent) of 1990 and SF6 emissions (in thousand metric tons of CO2 equivalent) of 2008 in Iceland?
Provide a short and direct response. -0.5. What is the difference between the SF6 emissions (in thousand metric tons of CO2 equivalent) of 2005 and SF6 emissions (in thousand metric tons of CO2 equivalent) of 2008 in Iceland?
Offer a very short reply. -0.5. What is the difference between the SF6 emissions (in thousand metric tons of CO2 equivalent) in 1990 and SF6 emissions (in thousand metric tons of CO2 equivalent) in 2000 in India?
Your answer should be compact. 2322.8. What is the difference between the SF6 emissions (in thousand metric tons of CO2 equivalent) of 1990 and SF6 emissions (in thousand metric tons of CO2 equivalent) of 2005 in India?
Your response must be concise. 1178.8. What is the difference between the SF6 emissions (in thousand metric tons of CO2 equivalent) of 1990 and SF6 emissions (in thousand metric tons of CO2 equivalent) of 2008 in India?
Your response must be concise. 456.1. What is the difference between the SF6 emissions (in thousand metric tons of CO2 equivalent) in 2000 and SF6 emissions (in thousand metric tons of CO2 equivalent) in 2005 in India?
Your response must be concise. -1144. What is the difference between the SF6 emissions (in thousand metric tons of CO2 equivalent) of 2000 and SF6 emissions (in thousand metric tons of CO2 equivalent) of 2008 in India?
Your answer should be compact. -1866.7. What is the difference between the SF6 emissions (in thousand metric tons of CO2 equivalent) of 2005 and SF6 emissions (in thousand metric tons of CO2 equivalent) of 2008 in India?
Offer a terse response. -722.7. What is the difference between the SF6 emissions (in thousand metric tons of CO2 equivalent) of 1990 and SF6 emissions (in thousand metric tons of CO2 equivalent) of 2000 in Indonesia?
Keep it short and to the point. 236. What is the difference between the SF6 emissions (in thousand metric tons of CO2 equivalent) in 1990 and SF6 emissions (in thousand metric tons of CO2 equivalent) in 2005 in Indonesia?
Provide a short and direct response. 176.7. What is the difference between the SF6 emissions (in thousand metric tons of CO2 equivalent) of 1990 and SF6 emissions (in thousand metric tons of CO2 equivalent) of 2008 in Indonesia?
Give a very brief answer. 46.4. What is the difference between the SF6 emissions (in thousand metric tons of CO2 equivalent) in 2000 and SF6 emissions (in thousand metric tons of CO2 equivalent) in 2005 in Indonesia?
Your answer should be very brief. -59.3. What is the difference between the SF6 emissions (in thousand metric tons of CO2 equivalent) in 2000 and SF6 emissions (in thousand metric tons of CO2 equivalent) in 2008 in Indonesia?
Offer a very short reply. -189.6. What is the difference between the SF6 emissions (in thousand metric tons of CO2 equivalent) of 2005 and SF6 emissions (in thousand metric tons of CO2 equivalent) of 2008 in Indonesia?
Offer a terse response. -130.3. What is the difference between the SF6 emissions (in thousand metric tons of CO2 equivalent) of 1990 and SF6 emissions (in thousand metric tons of CO2 equivalent) of 2000 in Iran?
Offer a terse response. 682.4. What is the difference between the SF6 emissions (in thousand metric tons of CO2 equivalent) in 1990 and SF6 emissions (in thousand metric tons of CO2 equivalent) in 2005 in Iran?
Your response must be concise. 31.8. What is the difference between the SF6 emissions (in thousand metric tons of CO2 equivalent) in 1990 and SF6 emissions (in thousand metric tons of CO2 equivalent) in 2008 in Iran?
Keep it short and to the point. -337.6. What is the difference between the SF6 emissions (in thousand metric tons of CO2 equivalent) of 2000 and SF6 emissions (in thousand metric tons of CO2 equivalent) of 2005 in Iran?
Give a very brief answer. -650.6. What is the difference between the SF6 emissions (in thousand metric tons of CO2 equivalent) in 2000 and SF6 emissions (in thousand metric tons of CO2 equivalent) in 2008 in Iran?
Ensure brevity in your answer.  -1020. What is the difference between the SF6 emissions (in thousand metric tons of CO2 equivalent) in 2005 and SF6 emissions (in thousand metric tons of CO2 equivalent) in 2008 in Iran?
Offer a terse response. -369.4. What is the difference between the SF6 emissions (in thousand metric tons of CO2 equivalent) in 1990 and SF6 emissions (in thousand metric tons of CO2 equivalent) in 2000 in Iraq?
Provide a short and direct response. 96.8. What is the difference between the SF6 emissions (in thousand metric tons of CO2 equivalent) of 1990 and SF6 emissions (in thousand metric tons of CO2 equivalent) of 2005 in Iraq?
Provide a succinct answer. 166.9. What is the difference between the SF6 emissions (in thousand metric tons of CO2 equivalent) in 1990 and SF6 emissions (in thousand metric tons of CO2 equivalent) in 2008 in Iraq?
Make the answer very short. 151.2. What is the difference between the SF6 emissions (in thousand metric tons of CO2 equivalent) of 2000 and SF6 emissions (in thousand metric tons of CO2 equivalent) of 2005 in Iraq?
Make the answer very short. 70.1. What is the difference between the SF6 emissions (in thousand metric tons of CO2 equivalent) of 2000 and SF6 emissions (in thousand metric tons of CO2 equivalent) of 2008 in Iraq?
Offer a terse response. 54.4. What is the difference between the SF6 emissions (in thousand metric tons of CO2 equivalent) of 2005 and SF6 emissions (in thousand metric tons of CO2 equivalent) of 2008 in Iraq?
Your answer should be very brief. -15.7. What is the ratio of the SF6 emissions (in thousand metric tons of CO2 equivalent) in 1990 in Hungary to that in Iceland?
Give a very brief answer. 5.31. What is the ratio of the SF6 emissions (in thousand metric tons of CO2 equivalent) of 2000 in Hungary to that in Iceland?
Provide a succinct answer. 1.41. What is the ratio of the SF6 emissions (in thousand metric tons of CO2 equivalent) of 2005 in Hungary to that in Iceland?
Offer a very short reply. 8.57. What is the ratio of the SF6 emissions (in thousand metric tons of CO2 equivalent) in 2008 in Hungary to that in Iceland?
Give a very brief answer. 7.22. What is the ratio of the SF6 emissions (in thousand metric tons of CO2 equivalent) of 1990 in Hungary to that in India?
Make the answer very short. 0. What is the ratio of the SF6 emissions (in thousand metric tons of CO2 equivalent) of 2000 in Hungary to that in India?
Offer a terse response. 0.01. What is the ratio of the SF6 emissions (in thousand metric tons of CO2 equivalent) of 2005 in Hungary to that in India?
Give a very brief answer. 0.01. What is the ratio of the SF6 emissions (in thousand metric tons of CO2 equivalent) of 2008 in Hungary to that in India?
Keep it short and to the point. 0.01. What is the ratio of the SF6 emissions (in thousand metric tons of CO2 equivalent) in 1990 in Hungary to that in Indonesia?
Give a very brief answer. 0.02. What is the ratio of the SF6 emissions (in thousand metric tons of CO2 equivalent) in 2000 in Hungary to that in Indonesia?
Offer a terse response. 0.03. What is the ratio of the SF6 emissions (in thousand metric tons of CO2 equivalent) of 2005 in Hungary to that in Indonesia?
Make the answer very short. 0.03. What is the ratio of the SF6 emissions (in thousand metric tons of CO2 equivalent) in 2008 in Hungary to that in Indonesia?
Ensure brevity in your answer.  0.03. What is the ratio of the SF6 emissions (in thousand metric tons of CO2 equivalent) in 1990 in Hungary to that in Iran?
Keep it short and to the point. 0.01. What is the ratio of the SF6 emissions (in thousand metric tons of CO2 equivalent) in 2000 in Hungary to that in Iran?
Give a very brief answer. 0.01. What is the ratio of the SF6 emissions (in thousand metric tons of CO2 equivalent) of 2005 in Hungary to that in Iran?
Offer a terse response. 0.01. What is the ratio of the SF6 emissions (in thousand metric tons of CO2 equivalent) of 2008 in Hungary to that in Iran?
Offer a terse response. 0.01. What is the ratio of the SF6 emissions (in thousand metric tons of CO2 equivalent) in 1990 in Hungary to that in Iraq?
Make the answer very short. 0.07. What is the ratio of the SF6 emissions (in thousand metric tons of CO2 equivalent) of 2000 in Hungary to that in Iraq?
Provide a short and direct response. 0.16. What is the ratio of the SF6 emissions (in thousand metric tons of CO2 equivalent) in 2005 in Hungary to that in Iraq?
Make the answer very short. 0.35. What is the ratio of the SF6 emissions (in thousand metric tons of CO2 equivalent) in 2008 in Hungary to that in Iraq?
Offer a very short reply. 0.28. What is the ratio of the SF6 emissions (in thousand metric tons of CO2 equivalent) of 1990 in Iceland to that in India?
Provide a short and direct response. 0. What is the ratio of the SF6 emissions (in thousand metric tons of CO2 equivalent) of 2000 in Iceland to that in India?
Provide a short and direct response. 0.01. What is the ratio of the SF6 emissions (in thousand metric tons of CO2 equivalent) of 2005 in Iceland to that in India?
Your answer should be very brief. 0. What is the ratio of the SF6 emissions (in thousand metric tons of CO2 equivalent) in 2008 in Iceland to that in India?
Your response must be concise. 0. What is the ratio of the SF6 emissions (in thousand metric tons of CO2 equivalent) in 1990 in Iceland to that in Indonesia?
Your response must be concise. 0. What is the ratio of the SF6 emissions (in thousand metric tons of CO2 equivalent) of 2000 in Iceland to that in Indonesia?
Provide a succinct answer. 0.02. What is the ratio of the SF6 emissions (in thousand metric tons of CO2 equivalent) in 2005 in Iceland to that in Indonesia?
Provide a succinct answer. 0. What is the ratio of the SF6 emissions (in thousand metric tons of CO2 equivalent) in 2008 in Iceland to that in Indonesia?
Make the answer very short. 0. What is the ratio of the SF6 emissions (in thousand metric tons of CO2 equivalent) in 1990 in Iceland to that in Iran?
Offer a very short reply. 0. What is the ratio of the SF6 emissions (in thousand metric tons of CO2 equivalent) in 2000 in Iceland to that in Iran?
Your answer should be compact. 0.01. What is the ratio of the SF6 emissions (in thousand metric tons of CO2 equivalent) in 2005 in Iceland to that in Iran?
Your response must be concise. 0. What is the ratio of the SF6 emissions (in thousand metric tons of CO2 equivalent) in 2008 in Iceland to that in Iran?
Make the answer very short. 0. What is the ratio of the SF6 emissions (in thousand metric tons of CO2 equivalent) of 1990 in Iceland to that in Iraq?
Provide a short and direct response. 0.01. What is the ratio of the SF6 emissions (in thousand metric tons of CO2 equivalent) in 2000 in Iceland to that in Iraq?
Provide a succinct answer. 0.11. What is the ratio of the SF6 emissions (in thousand metric tons of CO2 equivalent) in 2005 in Iceland to that in Iraq?
Your response must be concise. 0.04. What is the ratio of the SF6 emissions (in thousand metric tons of CO2 equivalent) in 2008 in Iceland to that in Iraq?
Make the answer very short. 0.04. What is the ratio of the SF6 emissions (in thousand metric tons of CO2 equivalent) in 1990 in India to that in Indonesia?
Provide a succinct answer. 5.42. What is the ratio of the SF6 emissions (in thousand metric tons of CO2 equivalent) of 2000 in India to that in Indonesia?
Provide a succinct answer. 4.15. What is the ratio of the SF6 emissions (in thousand metric tons of CO2 equivalent) of 2005 in India to that in Indonesia?
Make the answer very short. 5.17. What is the ratio of the SF6 emissions (in thousand metric tons of CO2 equivalent) of 2008 in India to that in Indonesia?
Give a very brief answer. 5.22. What is the ratio of the SF6 emissions (in thousand metric tons of CO2 equivalent) in 1990 in India to that in Iran?
Make the answer very short. 2.41. What is the ratio of the SF6 emissions (in thousand metric tons of CO2 equivalent) in 2000 in India to that in Iran?
Your answer should be very brief. 2.01. What is the ratio of the SF6 emissions (in thousand metric tons of CO2 equivalent) of 2005 in India to that in Iran?
Your answer should be compact. 1.94. What is the ratio of the SF6 emissions (in thousand metric tons of CO2 equivalent) in 2008 in India to that in Iran?
Your answer should be compact. 1.95. What is the ratio of the SF6 emissions (in thousand metric tons of CO2 equivalent) of 1990 in India to that in Iraq?
Keep it short and to the point. 22.77. What is the ratio of the SF6 emissions (in thousand metric tons of CO2 equivalent) of 2000 in India to that in Iraq?
Keep it short and to the point. 22. What is the ratio of the SF6 emissions (in thousand metric tons of CO2 equivalent) in 2005 in India to that in Iraq?
Keep it short and to the point. 53.24. What is the ratio of the SF6 emissions (in thousand metric tons of CO2 equivalent) of 2008 in India to that in Iraq?
Ensure brevity in your answer.  52.13. What is the ratio of the SF6 emissions (in thousand metric tons of CO2 equivalent) of 1990 in Indonesia to that in Iran?
Keep it short and to the point. 0.45. What is the ratio of the SF6 emissions (in thousand metric tons of CO2 equivalent) of 2000 in Indonesia to that in Iran?
Keep it short and to the point. 0.48. What is the ratio of the SF6 emissions (in thousand metric tons of CO2 equivalent) in 2005 in Indonesia to that in Iran?
Ensure brevity in your answer.  0.38. What is the ratio of the SF6 emissions (in thousand metric tons of CO2 equivalent) in 2008 in Indonesia to that in Iran?
Provide a short and direct response. 0.37. What is the ratio of the SF6 emissions (in thousand metric tons of CO2 equivalent) in 1990 in Indonesia to that in Iraq?
Give a very brief answer. 4.2. What is the ratio of the SF6 emissions (in thousand metric tons of CO2 equivalent) in 2000 in Indonesia to that in Iraq?
Make the answer very short. 5.3. What is the ratio of the SF6 emissions (in thousand metric tons of CO2 equivalent) in 2005 in Indonesia to that in Iraq?
Provide a succinct answer. 10.3. What is the ratio of the SF6 emissions (in thousand metric tons of CO2 equivalent) of 2008 in Indonesia to that in Iraq?
Your answer should be very brief. 9.99. What is the ratio of the SF6 emissions (in thousand metric tons of CO2 equivalent) in 1990 in Iran to that in Iraq?
Provide a succinct answer. 9.44. What is the ratio of the SF6 emissions (in thousand metric tons of CO2 equivalent) of 2000 in Iran to that in Iraq?
Give a very brief answer. 10.92. What is the ratio of the SF6 emissions (in thousand metric tons of CO2 equivalent) of 2005 in Iran to that in Iraq?
Ensure brevity in your answer.  27.39. What is the ratio of the SF6 emissions (in thousand metric tons of CO2 equivalent) in 2008 in Iran to that in Iraq?
Keep it short and to the point. 26.79. What is the difference between the highest and the second highest SF6 emissions (in thousand metric tons of CO2 equivalent) in 1990?
Provide a succinct answer. 3370.2. What is the difference between the highest and the second highest SF6 emissions (in thousand metric tons of CO2 equivalent) in 2000?
Offer a very short reply. 1729.8. What is the difference between the highest and the second highest SF6 emissions (in thousand metric tons of CO2 equivalent) in 2005?
Give a very brief answer. 2223.2. What is the difference between the highest and the second highest SF6 emissions (in thousand metric tons of CO2 equivalent) of 2008?
Your answer should be very brief. 2576.5. What is the difference between the highest and the lowest SF6 emissions (in thousand metric tons of CO2 equivalent) in 1990?
Your answer should be very brief. 5754. What is the difference between the highest and the lowest SF6 emissions (in thousand metric tons of CO2 equivalent) in 2000?
Offer a very short reply. 3416.8. What is the difference between the highest and the lowest SF6 emissions (in thousand metric tons of CO2 equivalent) in 2005?
Keep it short and to the point. 4575.2. What is the difference between the highest and the lowest SF6 emissions (in thousand metric tons of CO2 equivalent) of 2008?
Keep it short and to the point. 5297.4. 